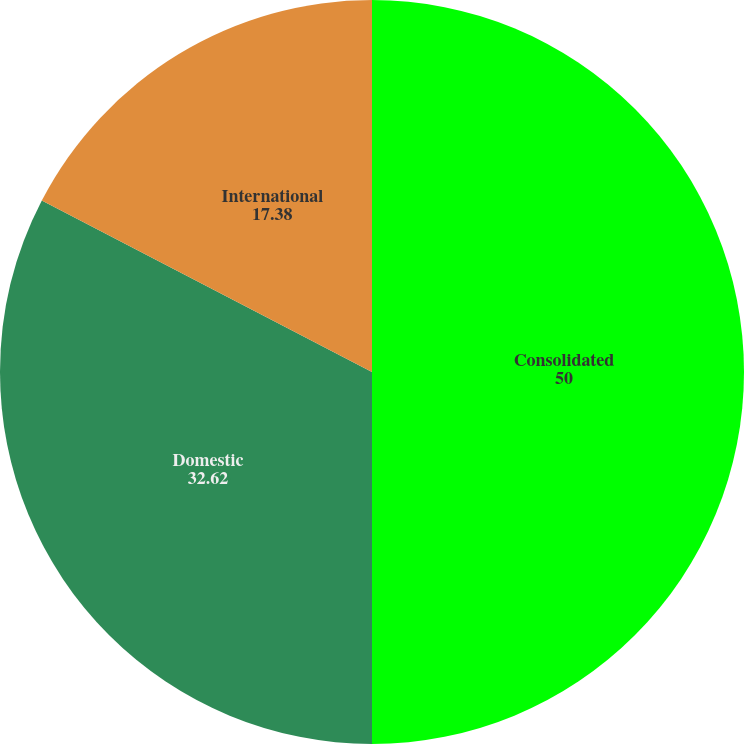Convert chart. <chart><loc_0><loc_0><loc_500><loc_500><pie_chart><fcel>Consolidated<fcel>Domestic<fcel>International<nl><fcel>50.0%<fcel>32.62%<fcel>17.38%<nl></chart> 